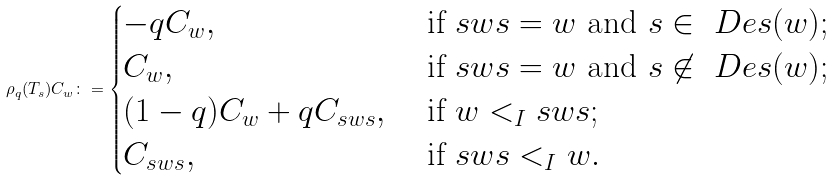<formula> <loc_0><loc_0><loc_500><loc_500>\rho _ { q } ( T _ { s } ) C _ { w } \colon = \begin{cases} - q C _ { w } , & \text { if } s w s = w \text { and } s \in \ D e s ( w ) ; \\ C _ { w } , & \text { if } s w s = w \text { and } s \not \in \ D e s ( w ) ; \\ ( 1 - q ) C _ { w } + q C _ { s w s } , & \text { if } w < _ { I } s w s ; \\ C _ { s w s } , & \text { if } s w s < _ { I } w . \end{cases}</formula> 